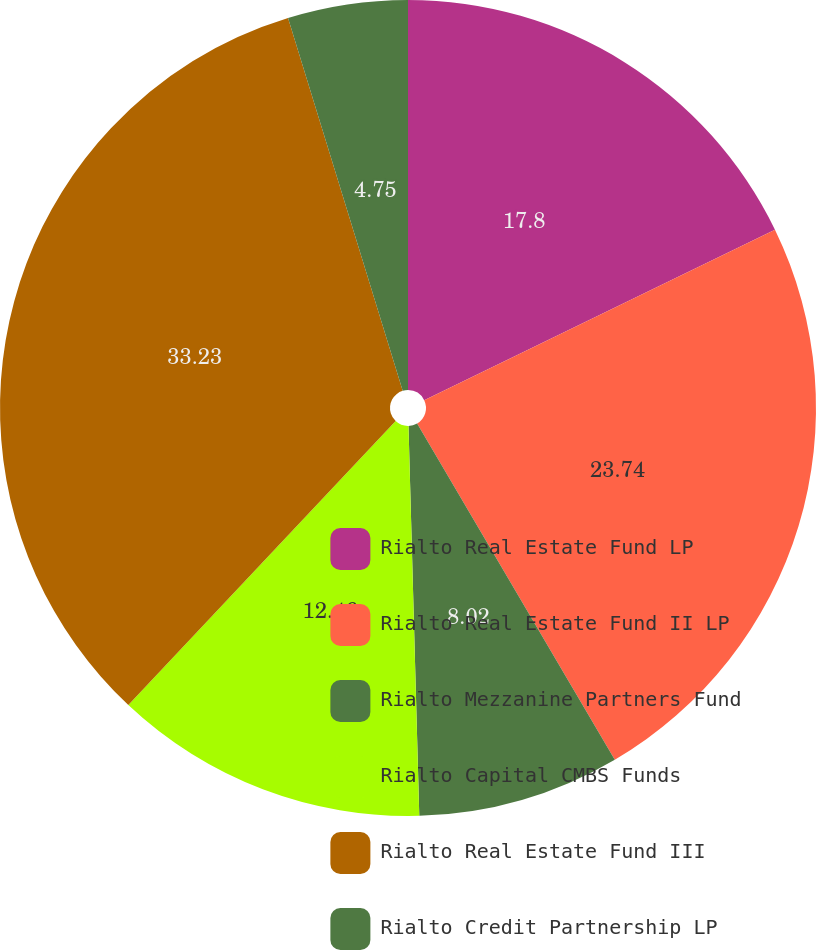Convert chart to OTSL. <chart><loc_0><loc_0><loc_500><loc_500><pie_chart><fcel>Rialto Real Estate Fund LP<fcel>Rialto Real Estate Fund II LP<fcel>Rialto Mezzanine Partners Fund<fcel>Rialto Capital CMBS Funds<fcel>Rialto Real Estate Fund III<fcel>Rialto Credit Partnership LP<nl><fcel>17.8%<fcel>23.74%<fcel>8.02%<fcel>12.46%<fcel>33.23%<fcel>4.75%<nl></chart> 